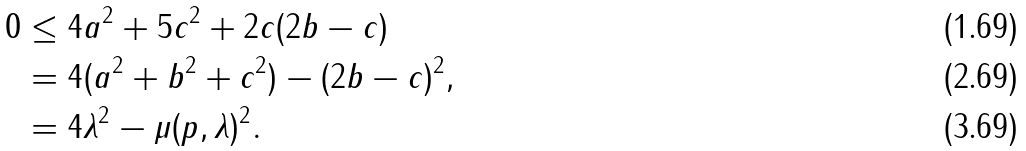Convert formula to latex. <formula><loc_0><loc_0><loc_500><loc_500>0 & \leq 4 a ^ { 2 } + 5 c ^ { 2 } + 2 c ( 2 b - c ) \\ & = 4 ( a ^ { 2 } + b ^ { 2 } + c ^ { 2 } ) - ( 2 b - c ) ^ { 2 } , \\ & = 4 \| \lambda \| ^ { 2 } - \mu ( p , \lambda ) ^ { 2 } .</formula> 